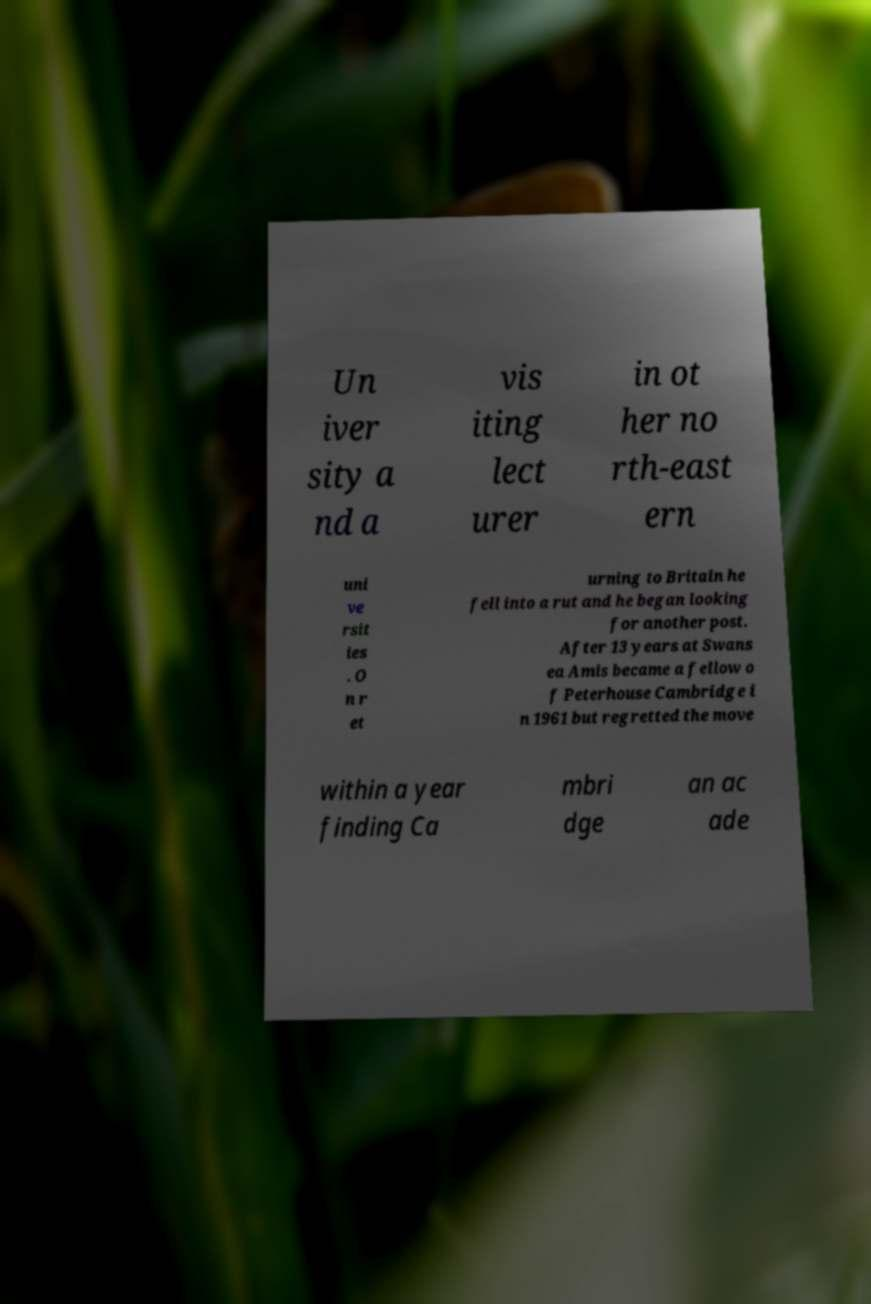I need the written content from this picture converted into text. Can you do that? Un iver sity a nd a vis iting lect urer in ot her no rth-east ern uni ve rsit ies . O n r et urning to Britain he fell into a rut and he began looking for another post. After 13 years at Swans ea Amis became a fellow o f Peterhouse Cambridge i n 1961 but regretted the move within a year finding Ca mbri dge an ac ade 